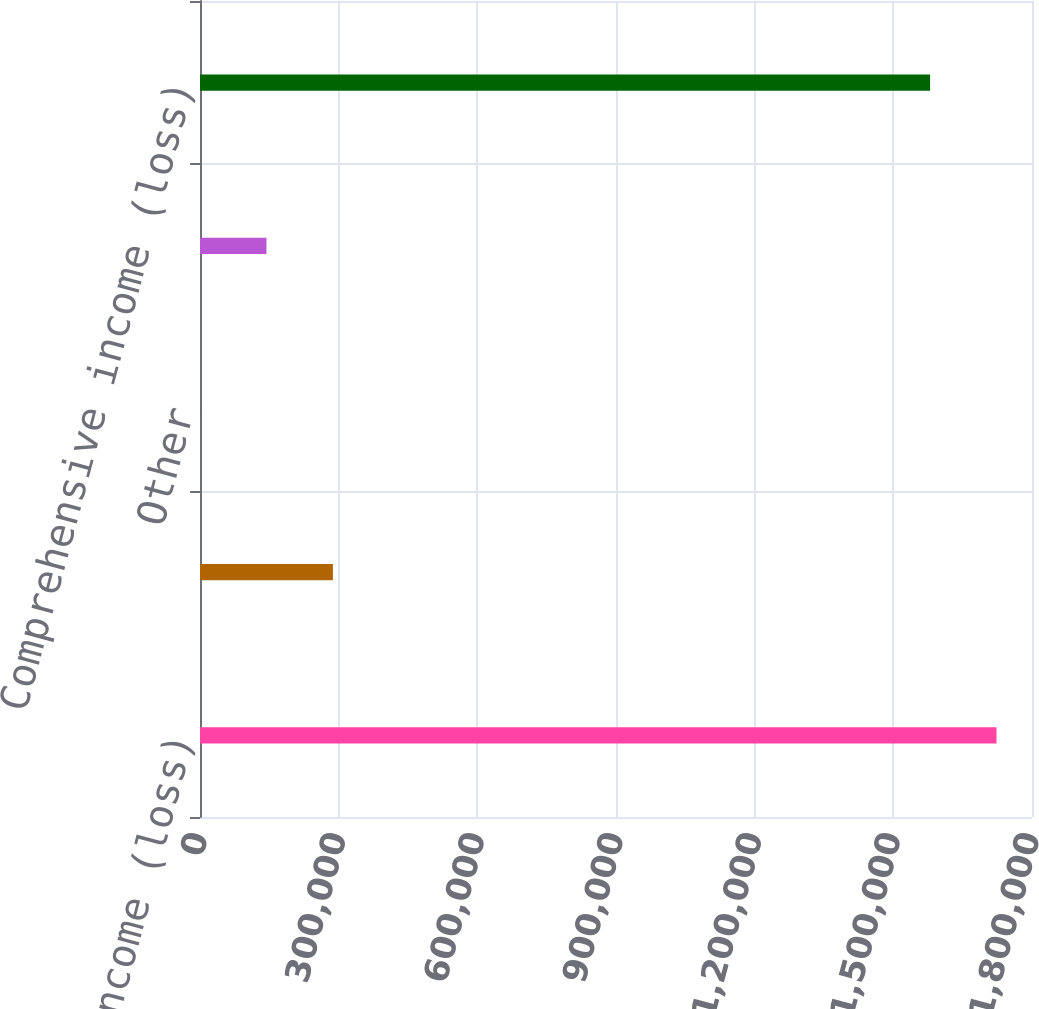<chart> <loc_0><loc_0><loc_500><loc_500><bar_chart><fcel>Net income (loss)<fcel>Foreign currency translation<fcel>Other<fcel>Other comprehensive income<fcel>Comprehensive income (loss)<nl><fcel>1.72323e+06<fcel>287535<fcel>70<fcel>143803<fcel>1.57949e+06<nl></chart> 